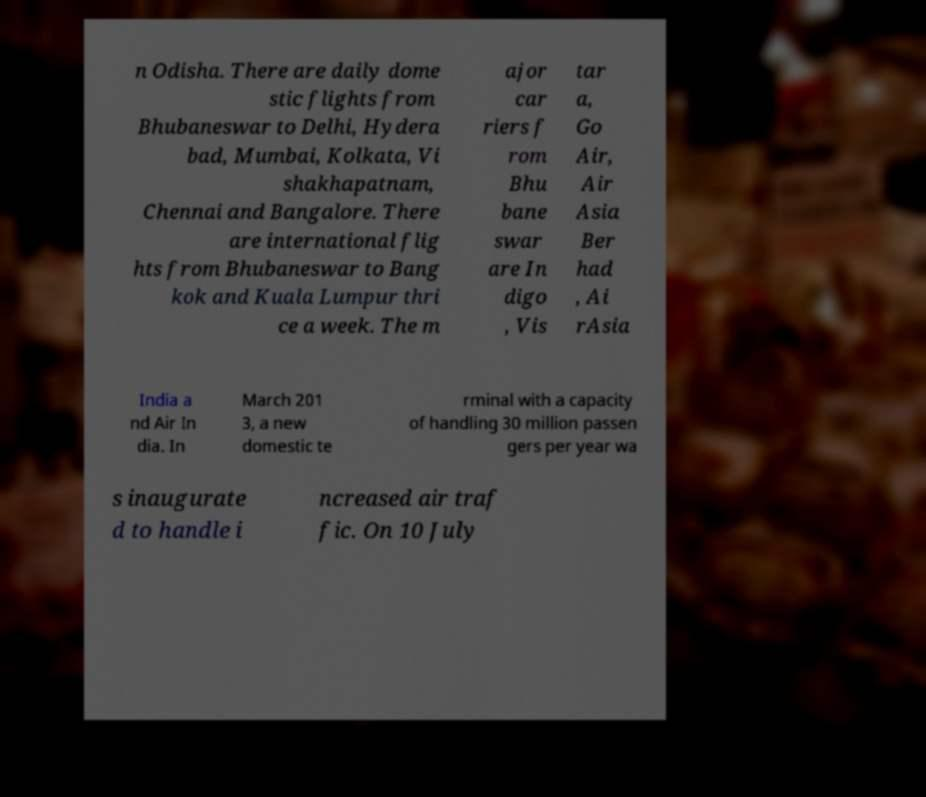Can you read and provide the text displayed in the image?This photo seems to have some interesting text. Can you extract and type it out for me? n Odisha. There are daily dome stic flights from Bhubaneswar to Delhi, Hydera bad, Mumbai, Kolkata, Vi shakhapatnam, Chennai and Bangalore. There are international flig hts from Bhubaneswar to Bang kok and Kuala Lumpur thri ce a week. The m ajor car riers f rom Bhu bane swar are In digo , Vis tar a, Go Air, Air Asia Ber had , Ai rAsia India a nd Air In dia. In March 201 3, a new domestic te rminal with a capacity of handling 30 million passen gers per year wa s inaugurate d to handle i ncreased air traf fic. On 10 July 